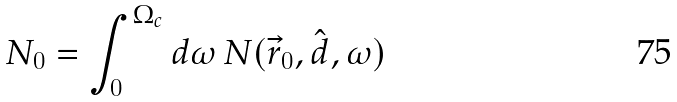<formula> <loc_0><loc_0><loc_500><loc_500>N _ { 0 } = \int _ { 0 } ^ { \Omega _ { c } } d \omega \, N ( \vec { r } _ { 0 } , \hat { d } , \omega )</formula> 